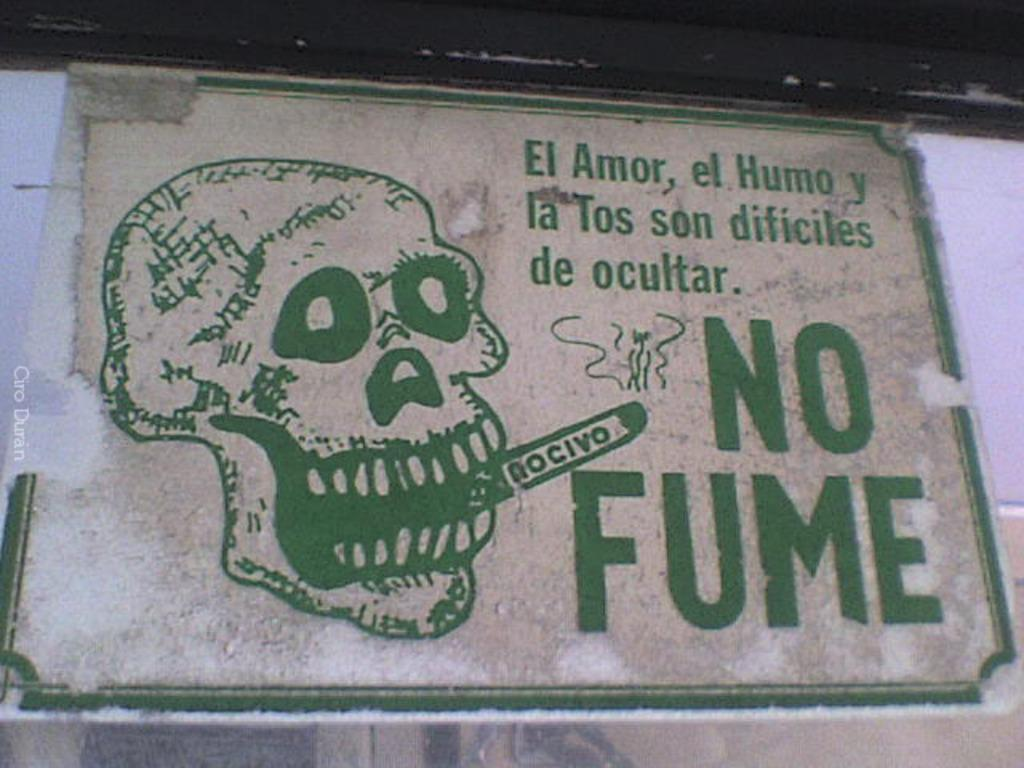What is the main object in the image? There is a board in the image. What can be seen on the board? Something is written on the board in green color. What type of apparatus is being used to capture the image of the board? There is no information about any apparatus or device used to capture the image; we are simply looking at a static image. Can you see any birds in the image? There is no mention of birds in the provided facts, so we cannot determine if there are any birds present in the image. 